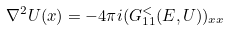Convert formula to latex. <formula><loc_0><loc_0><loc_500><loc_500>\nabla ^ { 2 } U ( x ) = - 4 \pi i ( G ^ { < } _ { 1 1 } ( E , U ) ) _ { x x }</formula> 